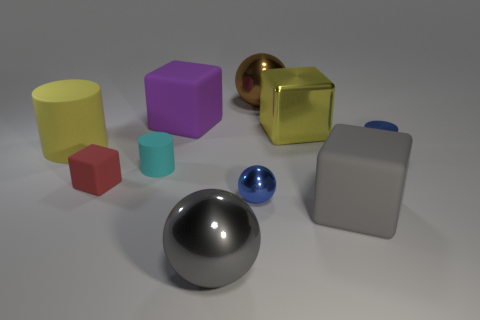Subtract 1 blocks. How many blocks are left? 3 Subtract all cylinders. How many objects are left? 7 Subtract all large gray metal balls. Subtract all brown balls. How many objects are left? 8 Add 4 yellow cylinders. How many yellow cylinders are left? 5 Add 5 large gray metal balls. How many large gray metal balls exist? 6 Subtract 1 brown balls. How many objects are left? 9 